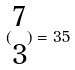<formula> <loc_0><loc_0><loc_500><loc_500>( \begin{matrix} 7 \\ 3 \end{matrix} ) = 3 5</formula> 